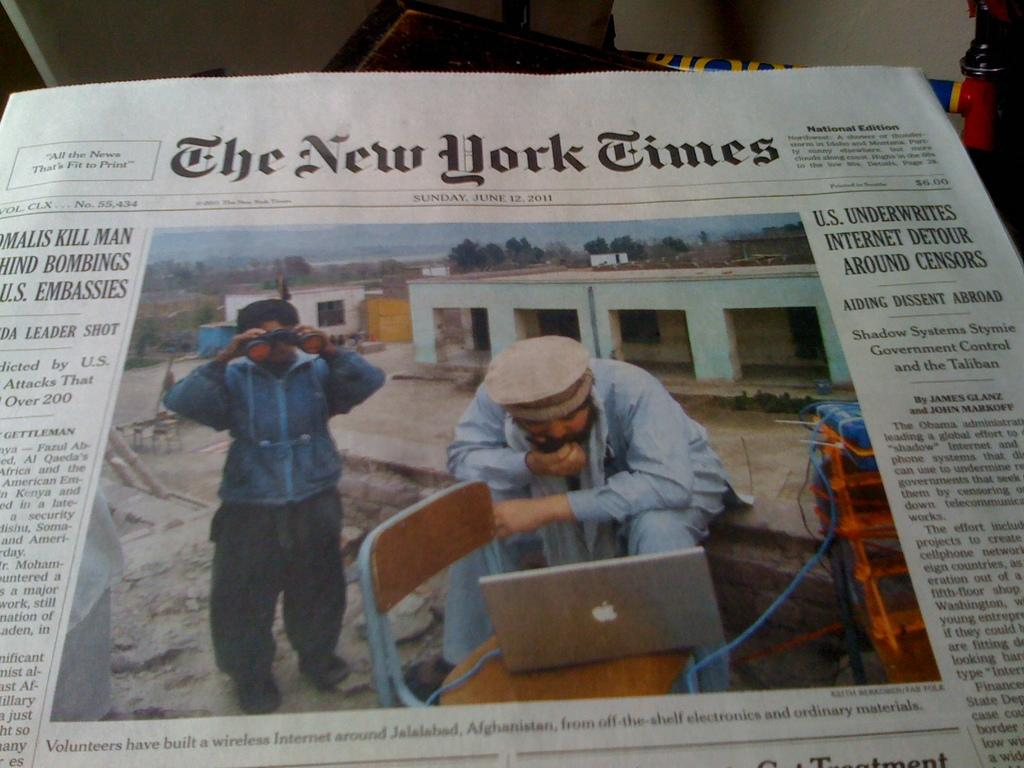What is placed on the table in the image? There is a newspaper on a table in the image. How many people are present in the image? There are at least two men in the image. What type of power source is visible in the image? There is no power source visible in the image. How does the breath of the men in the image affect the newspaper? The breath of the men in the image does not affect the newspaper, as there is no indication of them breathing on it. 